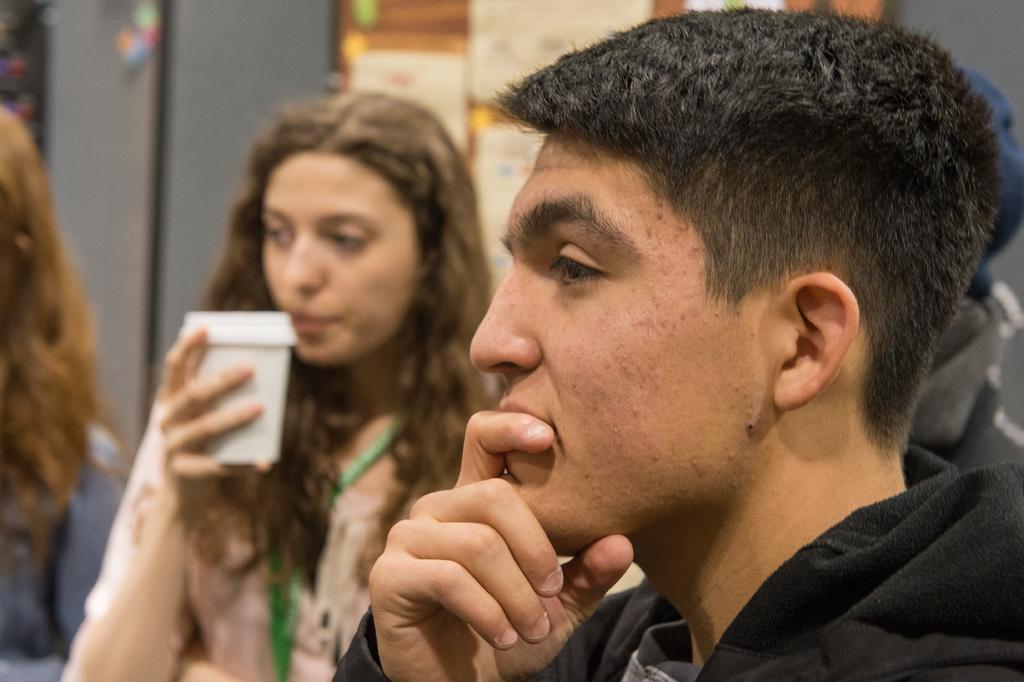Could you give a brief overview of what you see in this image? In this picture I can see there is a man sitting, he is wearing a hoodie and is looking at left and there is a person sitting next to him, there is a woman sitting, she is holding a glass and looking at left and there is a wall in the backdrop and there is a poster on the wall. 